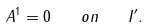<formula> <loc_0><loc_0><loc_500><loc_500>A ^ { 1 } = 0 \quad o n \quad I ^ { \prime } .</formula> 